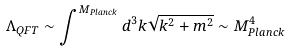Convert formula to latex. <formula><loc_0><loc_0><loc_500><loc_500>\Lambda _ { Q F T } \sim \int ^ { M _ { P l a n c k } } d ^ { 3 } k \sqrt { k ^ { 2 } + m ^ { 2 } } \sim M _ { P l a n c k } ^ { 4 }</formula> 